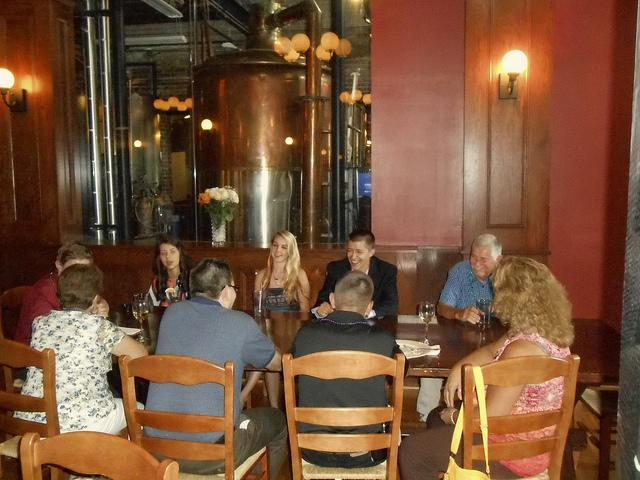What is the equipment in the background used for? brewing 